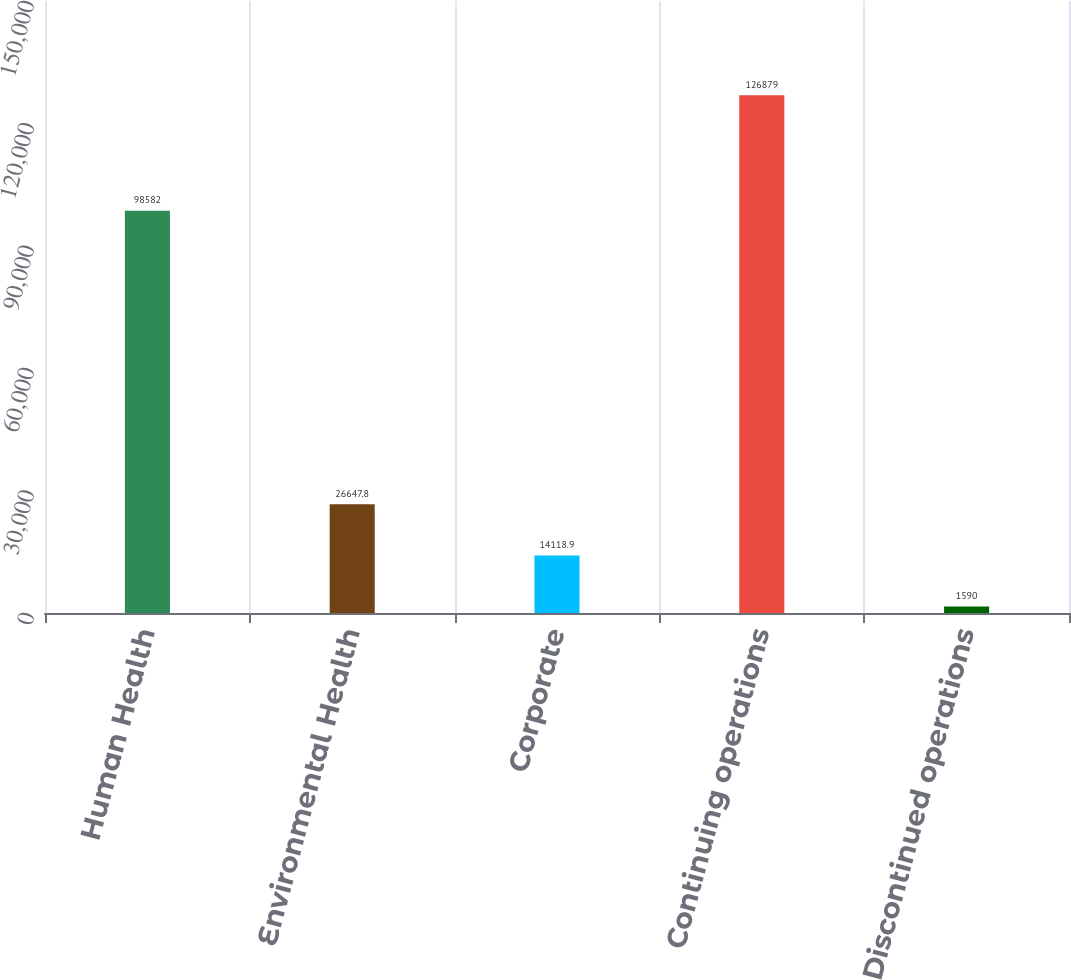Convert chart to OTSL. <chart><loc_0><loc_0><loc_500><loc_500><bar_chart><fcel>Human Health<fcel>Environmental Health<fcel>Corporate<fcel>Continuing operations<fcel>Discontinued operations<nl><fcel>98582<fcel>26647.8<fcel>14118.9<fcel>126879<fcel>1590<nl></chart> 